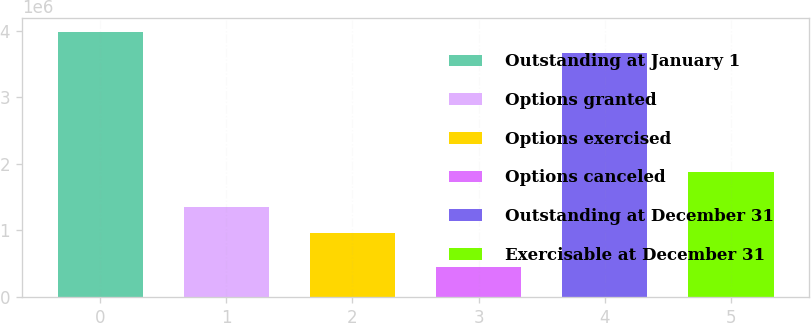Convert chart to OTSL. <chart><loc_0><loc_0><loc_500><loc_500><bar_chart><fcel>Outstanding at January 1<fcel>Options granted<fcel>Options exercised<fcel>Options canceled<fcel>Outstanding at December 31<fcel>Exercisable at December 31<nl><fcel>3.98969e+06<fcel>1.3508e+06<fcel>967945<fcel>446493<fcel>3.6618e+06<fcel>1.87426e+06<nl></chart> 